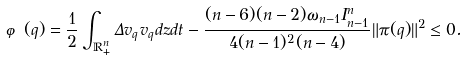Convert formula to latex. <formula><loc_0><loc_0><loc_500><loc_500>\varphi ( q ) = \frac { 1 } { 2 } \int _ { \mathbb { R } _ { + } ^ { n } } \Delta v _ { q } v _ { q } d z d t - \frac { ( n - 6 ) ( n - 2 ) \omega _ { n - 1 } I _ { n - 1 } ^ { n } } { 4 ( n - 1 ) ^ { 2 } ( n - 4 ) } \| \pi ( q ) \| ^ { 2 } \leq 0 .</formula> 